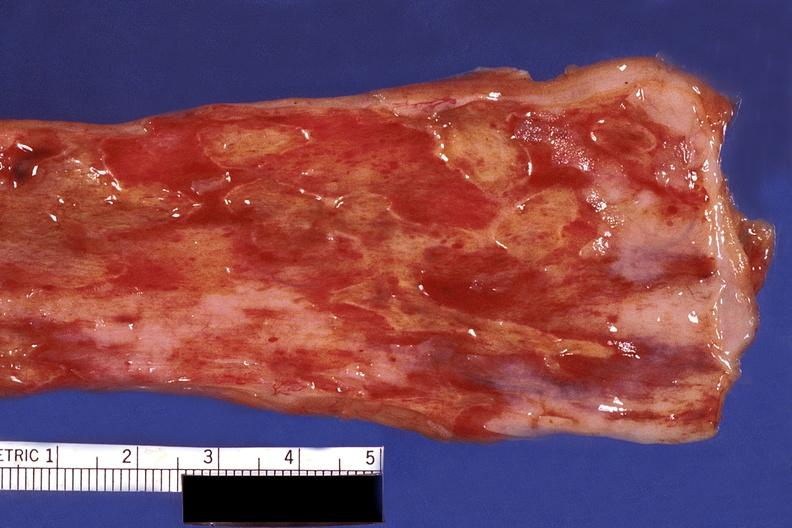what does this image show?
Answer the question using a single word or phrase. Esophagus 